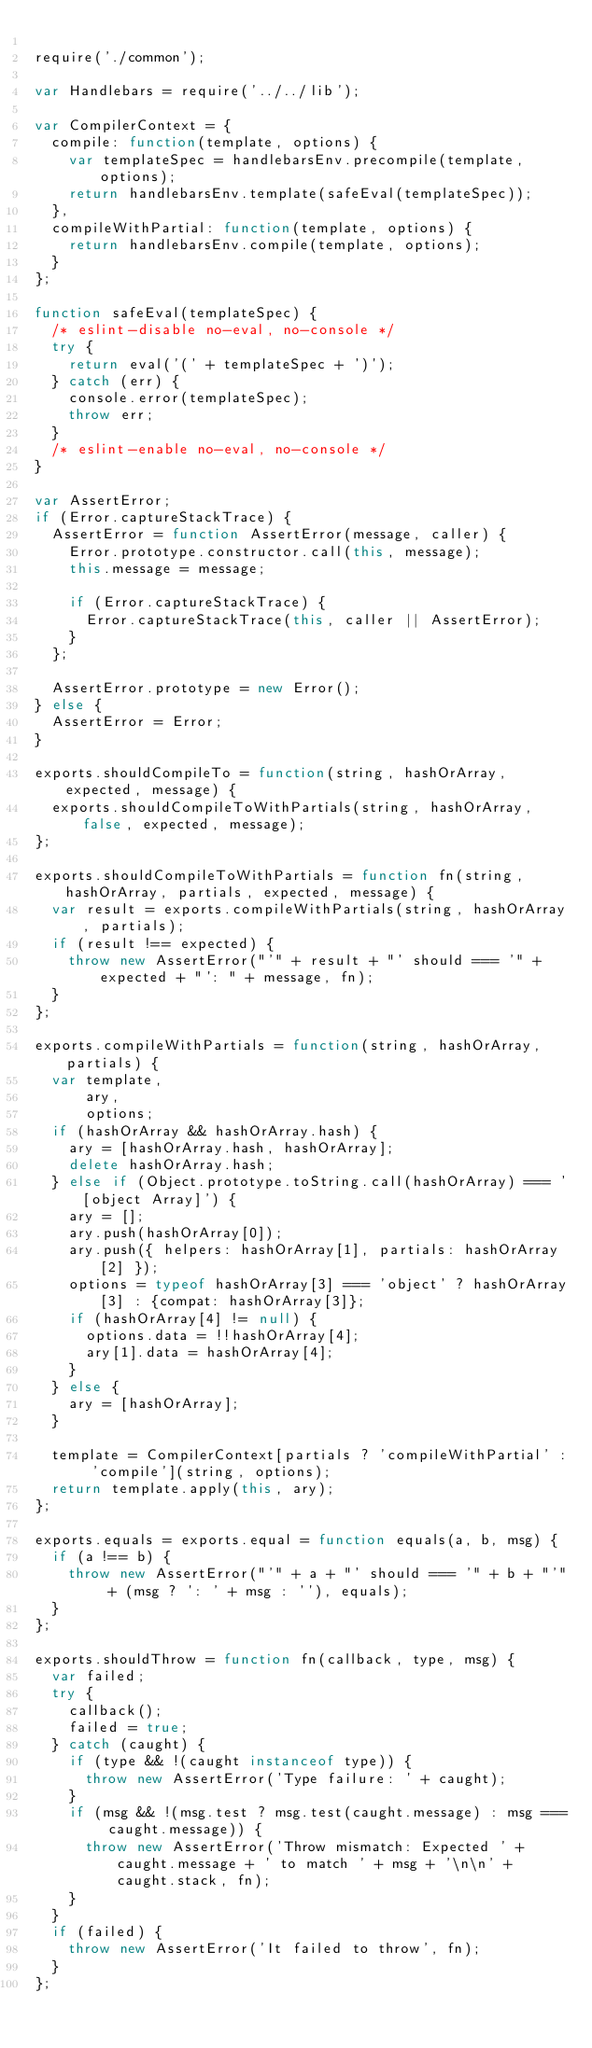<code> <loc_0><loc_0><loc_500><loc_500><_JavaScript_>
require('./common');

var Handlebars = require('../../lib');

var CompilerContext = {
  compile: function(template, options) {
    var templateSpec = handlebarsEnv.precompile(template, options);
    return handlebarsEnv.template(safeEval(templateSpec));
  },
  compileWithPartial: function(template, options) {
    return handlebarsEnv.compile(template, options);
  }
};

function safeEval(templateSpec) {
  /* eslint-disable no-eval, no-console */
  try {
    return eval('(' + templateSpec + ')');
  } catch (err) {
    console.error(templateSpec);
    throw err;
  }
  /* eslint-enable no-eval, no-console */
}

var AssertError;
if (Error.captureStackTrace) {
  AssertError = function AssertError(message, caller) {
    Error.prototype.constructor.call(this, message);
    this.message = message;

    if (Error.captureStackTrace) {
      Error.captureStackTrace(this, caller || AssertError);
    }
  };

  AssertError.prototype = new Error();
} else {
  AssertError = Error;
}

exports.shouldCompileTo = function(string, hashOrArray, expected, message) {
  exports.shouldCompileToWithPartials(string, hashOrArray, false, expected, message);
};

exports.shouldCompileToWithPartials = function fn(string, hashOrArray, partials, expected, message) {
  var result = exports.compileWithPartials(string, hashOrArray, partials);
  if (result !== expected) {
    throw new AssertError("'" + result + "' should === '" + expected + "': " + message, fn);
  }
};

exports.compileWithPartials = function(string, hashOrArray, partials) {
  var template,
      ary,
      options;
  if (hashOrArray && hashOrArray.hash) {
    ary = [hashOrArray.hash, hashOrArray];
    delete hashOrArray.hash;
  } else if (Object.prototype.toString.call(hashOrArray) === '[object Array]') {
    ary = [];
    ary.push(hashOrArray[0]);
    ary.push({ helpers: hashOrArray[1], partials: hashOrArray[2] });
    options = typeof hashOrArray[3] === 'object' ? hashOrArray[3] : {compat: hashOrArray[3]};
    if (hashOrArray[4] != null) {
      options.data = !!hashOrArray[4];
      ary[1].data = hashOrArray[4];
    }
  } else {
    ary = [hashOrArray];
  }

  template = CompilerContext[partials ? 'compileWithPartial' : 'compile'](string, options);
  return template.apply(this, ary);
};

exports.equals = exports.equal = function equals(a, b, msg) {
  if (a !== b) {
    throw new AssertError("'" + a + "' should === '" + b + "'" + (msg ? ': ' + msg : ''), equals);
  }
};

exports.shouldThrow = function fn(callback, type, msg) {
  var failed;
  try {
    callback();
    failed = true;
  } catch (caught) {
    if (type && !(caught instanceof type)) {
      throw new AssertError('Type failure: ' + caught);
    }
    if (msg && !(msg.test ? msg.test(caught.message) : msg === caught.message)) {
      throw new AssertError('Throw mismatch: Expected ' + caught.message + ' to match ' + msg + '\n\n' + caught.stack, fn);
    }
  }
  if (failed) {
    throw new AssertError('It failed to throw', fn);
  }
};
</code> 